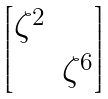Convert formula to latex. <formula><loc_0><loc_0><loc_500><loc_500>\begin{bmatrix} \zeta ^ { 2 } & \\ & \zeta ^ { 6 } \end{bmatrix}</formula> 